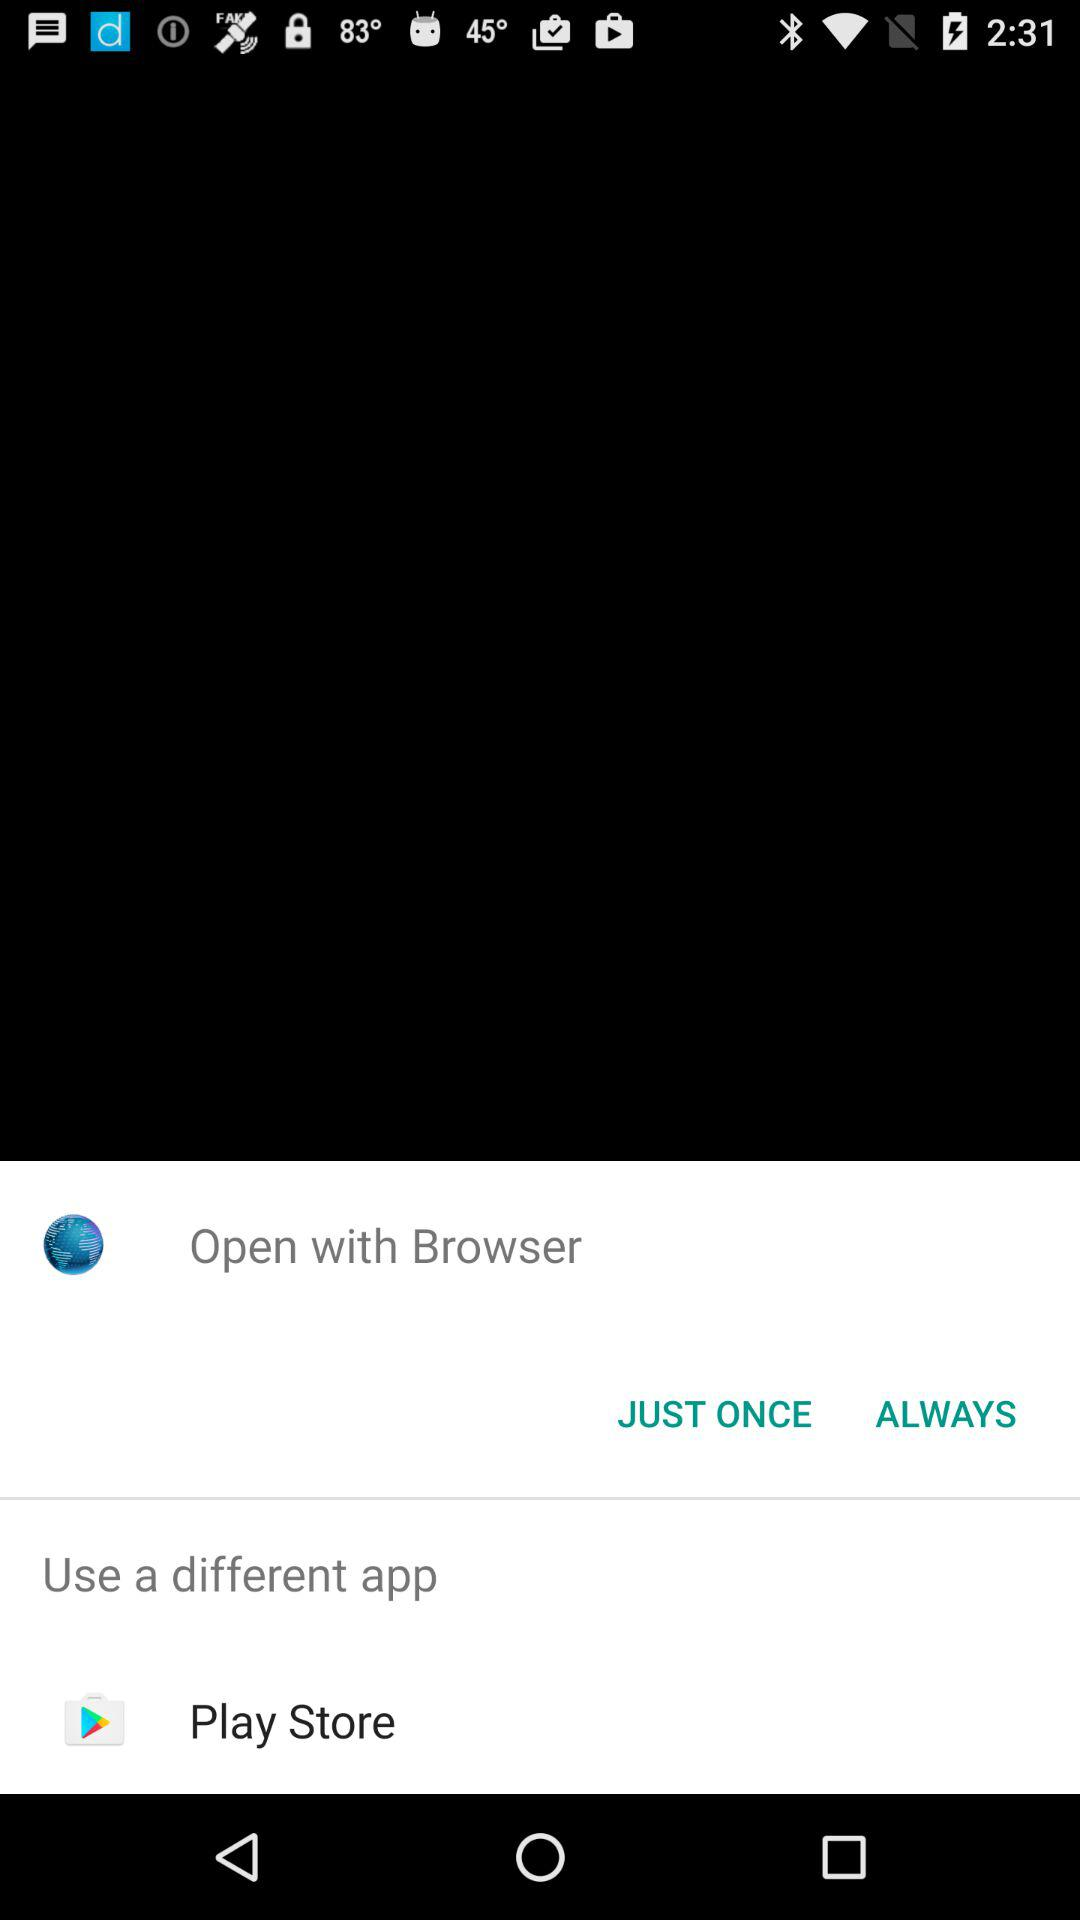What are the different apps that can be used to open the content? The application is "Play Store". 